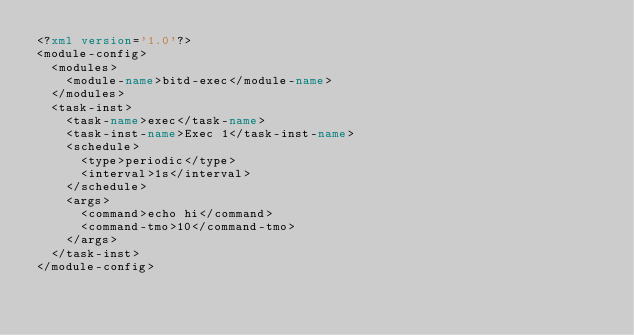Convert code to text. <code><loc_0><loc_0><loc_500><loc_500><_XML_><?xml version='1.0'?>
<module-config>
  <modules>
    <module-name>bitd-exec</module-name>
  </modules>
  <task-inst>
    <task-name>exec</task-name>  
    <task-inst-name>Exec 1</task-inst-name>  
    <schedule>
      <type>periodic</type>
      <interval>1s</interval>
    </schedule>  
    <args>
      <command>echo hi</command>
      <command-tmo>10</command-tmo>
    </args>
  </task-inst>
</module-config>
</code> 